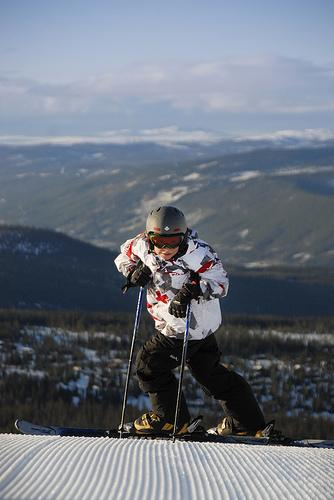Mention any possible landmarks or features of the landscape in the described image. Snowy mountains on the horizon, partly cloudy sky above mountains, white top of the ski slope, and snow on the ground among trees. Please describe the accessories used by the person in the image for skiing. The skier is using snow skis, two blue and black ski poles, and yellow and black ski boots to perform his skiing activity. List five plausible questions that can be framed for this image in a multi-choice VQA setting. 5. How is the weather depicted in the image? (Cloudy, Sunny, Stormy, Rainy) Briefly summarize the major components in the image that support the visual entailment task. Major components include the skier wearing winter gear, ski equipment, snowy setting, and the landscape supporting skiing activity, thereby visually implying a skiing scene. What type of activity is the person participating in, and mention some gear they are using. The person is participating in skiing activity, using snow skis, ski poles, and ski boots as their gear. What are the main colors of the sky, the jacket, and the boots? The sky is blue, the jacket is white, and the boots are yellow and black. What is the main activity taking place in this scene, and the focus of this activity? A person is standing on skis at the top of a slope, wearing a winter jacket and a helmet, preparing to ski down. Identify the gear being worn by the person in the image. The skier is wearing a gray helmet, tinted goggles, a white winter jacket, trousers, gloves, and yellow and black ski boots. Give a comprehensive description of the environment from the top to the bottom. The sky is blue with some clouds, and there are snowy mountains on the horizon. The ground has snow covering it with lines on the surface, possibly from skiing. How is this image appropriate for a product advertisement task? The image showcases various winter sports products like skis, poles, boots, helmet, goggles, and clothing, making it suitable for advertising winter sports gear. 